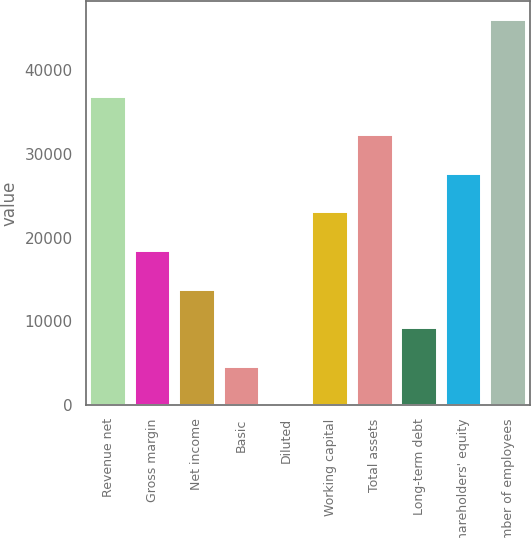Convert chart to OTSL. <chart><loc_0><loc_0><loc_500><loc_500><bar_chart><fcel>Revenue net<fcel>Gross margin<fcel>Net income<fcel>Basic<fcel>Diluted<fcel>Working capital<fcel>Total assets<fcel>Long-term debt<fcel>Shareholders' equity<fcel>Number of employees<nl><fcel>36793.2<fcel>18397.6<fcel>13798.8<fcel>4600.97<fcel>2.08<fcel>22996.5<fcel>32194.3<fcel>9199.86<fcel>27595.4<fcel>45991<nl></chart> 